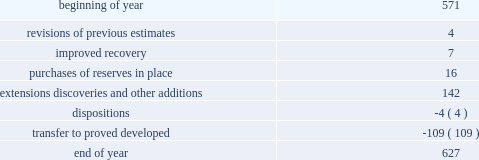Changes in proved undeveloped reserves as of december 31 , 2013 , 627 mmboe of proved undeveloped reserves were reported , an increase of 56 mmboe from december 31 , 2012 .
The table shows changes in total proved undeveloped reserves for 2013 : ( mmboe ) .
Significant additions to proved undeveloped reserves during 2013 included 72 mmboe in the eagle ford and 49 mmboe in the bakken shale plays due to development drilling .
Transfers from proved undeveloped to proved developed reserves included 57 mmboe in the eagle ford , 18 mmboe in the bakken and 7 mmboe in the oklahoma resource basins due to producing wells .
Costs incurred in 2013 , 2012 and 2011 relating to the development of proved undeveloped reserves , were $ 2536 million , $ 1995 million and $ 1107 million .
A total of 59 mmboe was booked as a result of reliable technology .
Technologies included statistical analysis of production performance , decline curve analysis , rate transient analysis , reservoir simulation and volumetric analysis .
The statistical nature of production performance coupled with highly certain reservoir continuity or quality within the reliable technology areas and sufficient proved undeveloped locations establish the reasonable certainty criteria required for booking reserves .
Projects can remain in proved undeveloped reserves for extended periods in certain situations such as large development projects which take more than five years to complete , or the timing of when additional gas compression is needed .
Of the 627 mmboe of proved undeveloped reserves at december 31 , 2013 , 24 percent of the volume is associated with projects that have been included in proved reserves for more than five years .
The majority of this volume is related to a compression project in e.g .
That was sanctioned by our board of directors in 2004 .
The timing of the installation of compression is being driven by the reservoir performance with this project intended to maintain maximum production levels .
Performance of this field since the board sanctioned the project has far exceeded expectations .
Estimates of initial dry gas in place increased by roughly 10 percent between 2004 and 2010 .
During 2012 , the compression project received the approval of the e.g .
Government , allowing design and planning work to progress towards implementation , with completion expected by mid-2016 .
The other component of alba proved undeveloped reserves is an infill well approved in 2013 and to be drilled late 2014 .
Proved undeveloped reserves for the north gialo development , located in the libyan sahara desert , were booked for the first time as proved undeveloped reserves in 2010 .
This development , which is anticipated to take more than five years to be developed , is being executed by the operator and encompasses a continuous drilling program including the design , fabrication and installation of extensive liquid handling and gas recycling facilities .
Anecdotal evidence from similar development projects in the region led to an expected project execution of more than five years from the time the reserves were initially booked .
Interruptions associated with the civil unrest in 2011 and third-party labor strikes in 2013 have extended the project duration .
There are no other significant undeveloped reserves expected to be developed more than five years after their original booking .
As of december 31 , 2013 , future development costs estimated to be required for the development of proved undeveloped liquid hydrocarbon , natural gas and synthetic crude oil reserves related to continuing operations for the years 2014 through 2018 are projected to be $ 2894 million , $ 2567 million , $ 2020 million , $ 1452 million and $ 575 million .
The timing of future projects and estimated future development costs relating to the development of proved undeveloped liquid hydrocarbon , natural gas and synthetic crude oil reserves are forward-looking statements and are based on a number of assumptions , including ( among others ) commodity prices , presently known physical data concerning size and character of the reservoirs , economic recoverability , technology developments , future drilling success , industry economic conditions , levels of cash flow from operations , production experience and other operating considerations .
To the extent these assumptions prove inaccurate , actual recoveries , timing and development costs could be different than current estimates. .
Of total proven undeveloped reserves , how much consisted of extensions discoveries and other additions? 
Computations: (142 / 627)
Answer: 0.22648. 